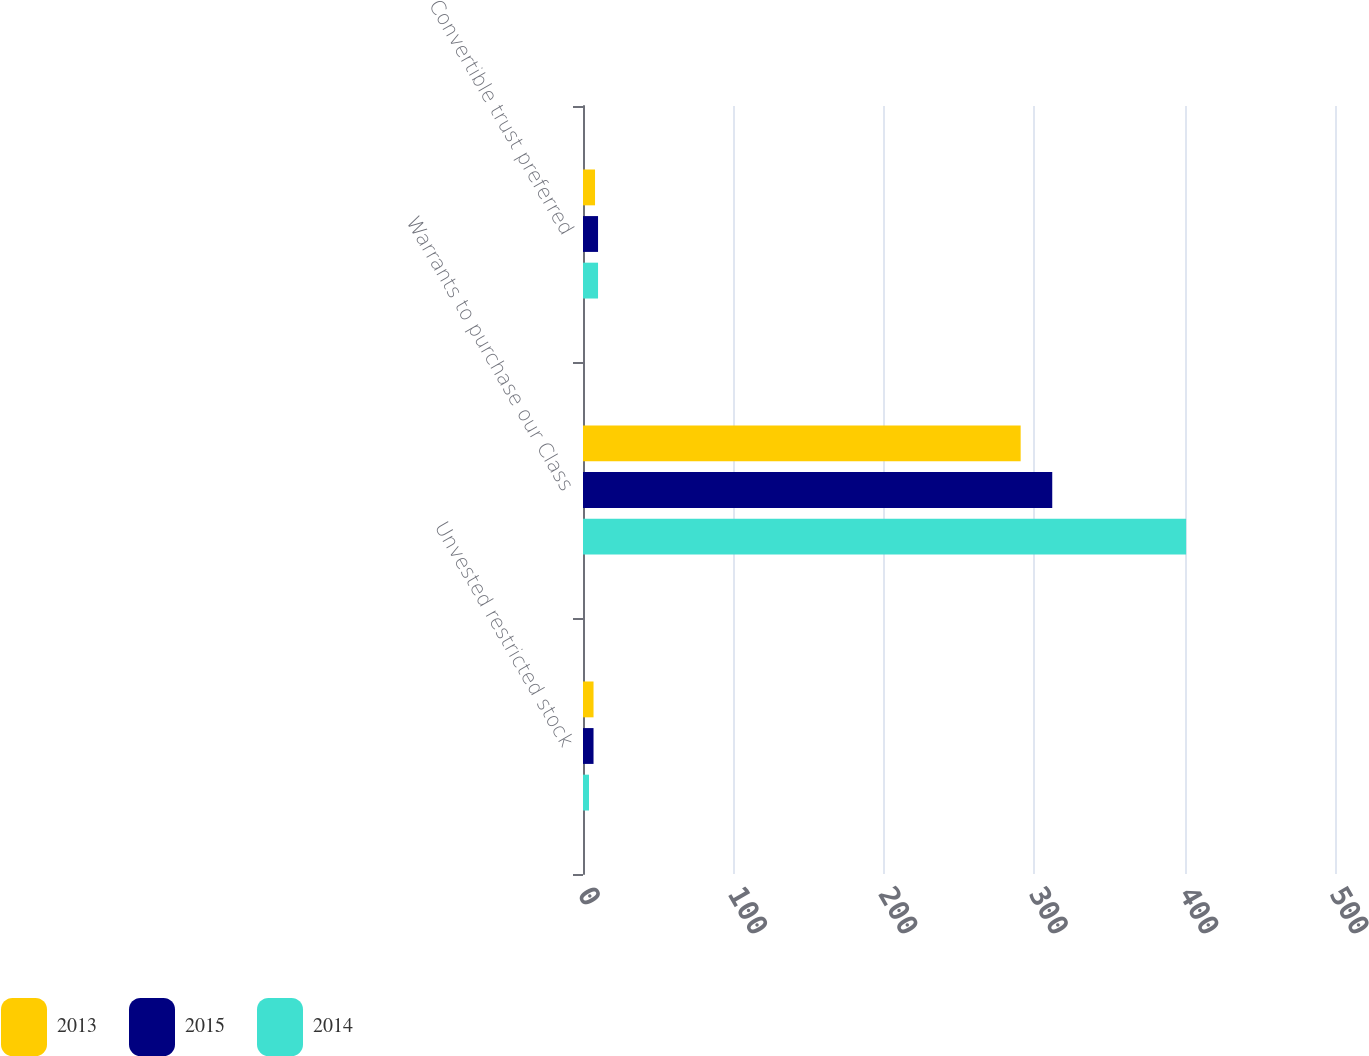Convert chart to OTSL. <chart><loc_0><loc_0><loc_500><loc_500><stacked_bar_chart><ecel><fcel>Unvested restricted stock<fcel>Warrants to purchase our Class<fcel>Convertible trust preferred<nl><fcel>2013<fcel>7<fcel>291<fcel>8<nl><fcel>2015<fcel>7<fcel>312<fcel>10<nl><fcel>2014<fcel>4<fcel>401<fcel>10<nl></chart> 